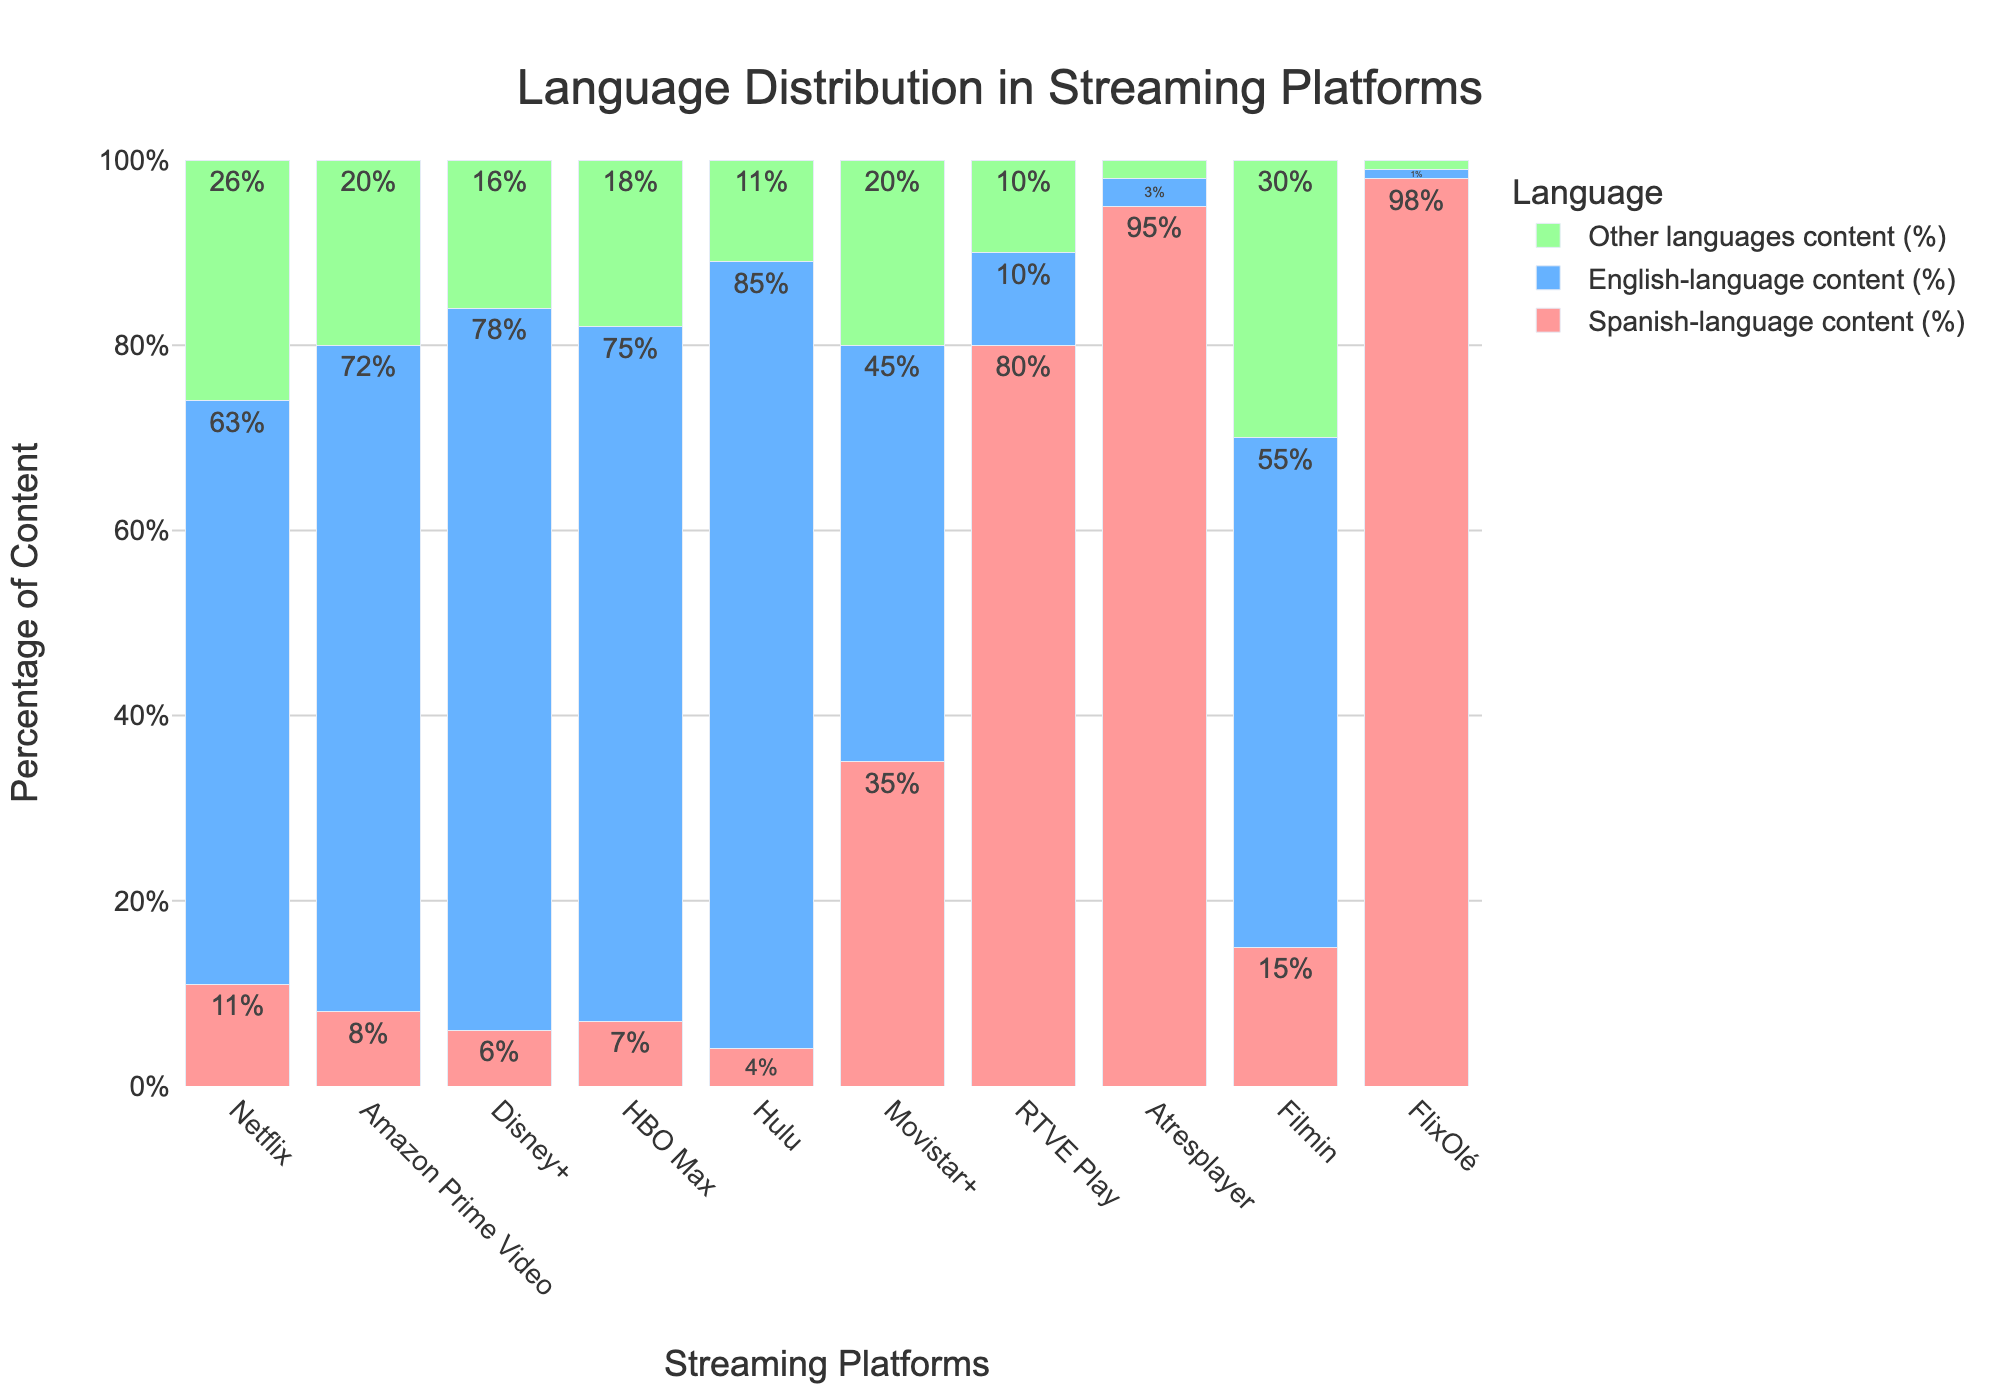What's the platform with the highest percentage of Spanish-language content? Look at the bar representing Spanish-language content for each platform. The tallest bar indicates the highest percentage.
Answer: FlixOlé Which platform offers the highest percentage of English-language content? Identify the tallest bar among the English-language content bars across all platforms.
Answer: Hulu What is the difference between the percentage of Spanish-language content on Movistar+ and Filmin? Subtract the percentage of Spanish-language content on Filmin from that on Movistar+.
Answer: 35% - 15% = 20% Which platform has the greatest disparity between Spanish and English-language content? Compare the differences between Spanish and English-language content on each platform by looking at the bars' lengths for these categories.
Answer: Atresplayer Among Netflix, Amazon Prime Video, and Disney+, which platform has the smallest percentage of content in languages other than Spanish and English? Compare the height of the bars representing "Other languages content" for Netflix, Amazon Prime Video, and Disney+. Identify the shortest bar.
Answer: Disney+ How does the percentage of other languages content on RTVE Play compare to its Spanish-language content? Look at the heights of the 'Other languages content' and 'Spanish-language content' bars for RTVE Play and compare them.
Answer: Spanish-language content (80%) is much higher than Other languages content (10%) What is the combined percentage of Spanish-language and other languages content on Netflix? Add the percentage of Spanish-language content and other languages content on Netflix.
Answer: 11% + 26% = 37% Which platform has the widest variety in language distribution indicated by the proportions of all three languages? Look for the platform where there is less dominance of any single language, indicated by more evenly distributed bar lengths for Spanish, English, and other languages.
Answer: Filmin What's the median percentage value of Spanish-language content across all platforms? List the Spanish-language content percentages and find the middle value: 4%, 6%, 7%, 8%, 11%, 15%, 35%, 80%, 95%, 98%.
Answer: Median = (8% + 11%) / 2 = 9.5% 